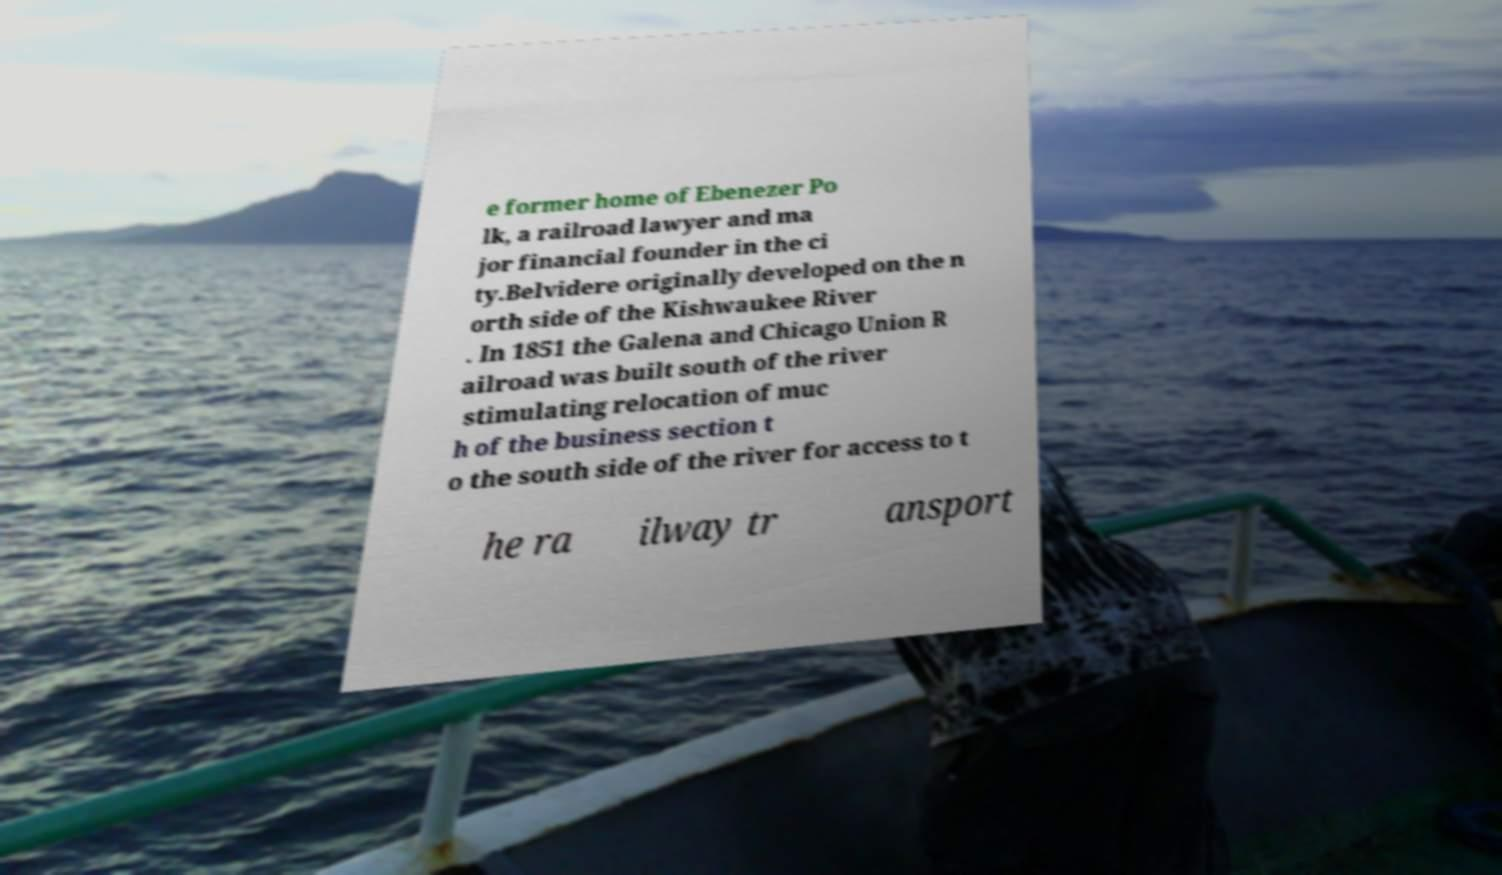Could you assist in decoding the text presented in this image and type it out clearly? e former home of Ebenezer Po lk, a railroad lawyer and ma jor financial founder in the ci ty.Belvidere originally developed on the n orth side of the Kishwaukee River . In 1851 the Galena and Chicago Union R ailroad was built south of the river stimulating relocation of muc h of the business section t o the south side of the river for access to t he ra ilway tr ansport 